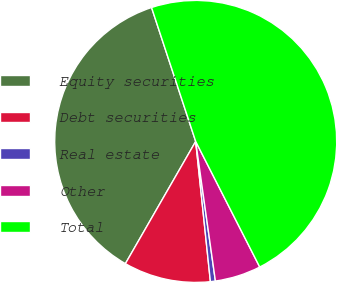<chart> <loc_0><loc_0><loc_500><loc_500><pie_chart><fcel>Equity securities<fcel>Debt securities<fcel>Real estate<fcel>Other<fcel>Total<nl><fcel>36.62%<fcel>9.97%<fcel>0.57%<fcel>5.27%<fcel>47.56%<nl></chart> 